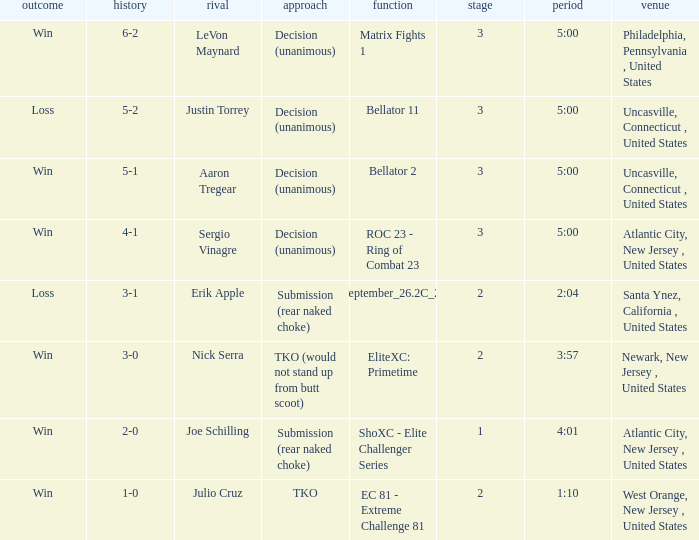Give me the full table as a dictionary. {'header': ['outcome', 'history', 'rival', 'approach', 'function', 'stage', 'period', 'venue'], 'rows': [['Win', '6-2', 'LeVon Maynard', 'Decision (unanimous)', 'Matrix Fights 1', '3', '5:00', 'Philadelphia, Pennsylvania , United States'], ['Loss', '5-2', 'Justin Torrey', 'Decision (unanimous)', 'Bellator 11', '3', '5:00', 'Uncasville, Connecticut , United States'], ['Win', '5-1', 'Aaron Tregear', 'Decision (unanimous)', 'Bellator 2', '3', '5:00', 'Uncasville, Connecticut , United States'], ['Win', '4-1', 'Sergio Vinagre', 'Decision (unanimous)', 'ROC 23 - Ring of Combat 23', '3', '5:00', 'Atlantic City, New Jersey , United States'], ['Loss', '3-1', 'Erik Apple', 'Submission (rear naked choke)', 'ShoXC#September_26.2C_2008_card', '2', '2:04', 'Santa Ynez, California , United States'], ['Win', '3-0', 'Nick Serra', 'TKO (would not stand up from butt scoot)', 'EliteXC: Primetime', '2', '3:57', 'Newark, New Jersey , United States'], ['Win', '2-0', 'Joe Schilling', 'Submission (rear naked choke)', 'ShoXC - Elite Challenger Series', '1', '4:01', 'Atlantic City, New Jersey , United States'], ['Win', '1-0', 'Julio Cruz', 'TKO', 'EC 81 - Extreme Challenge 81', '2', '1:10', 'West Orange, New Jersey , United States']]} What was the round that Sergio Vinagre had a time of 5:00? 3.0. 